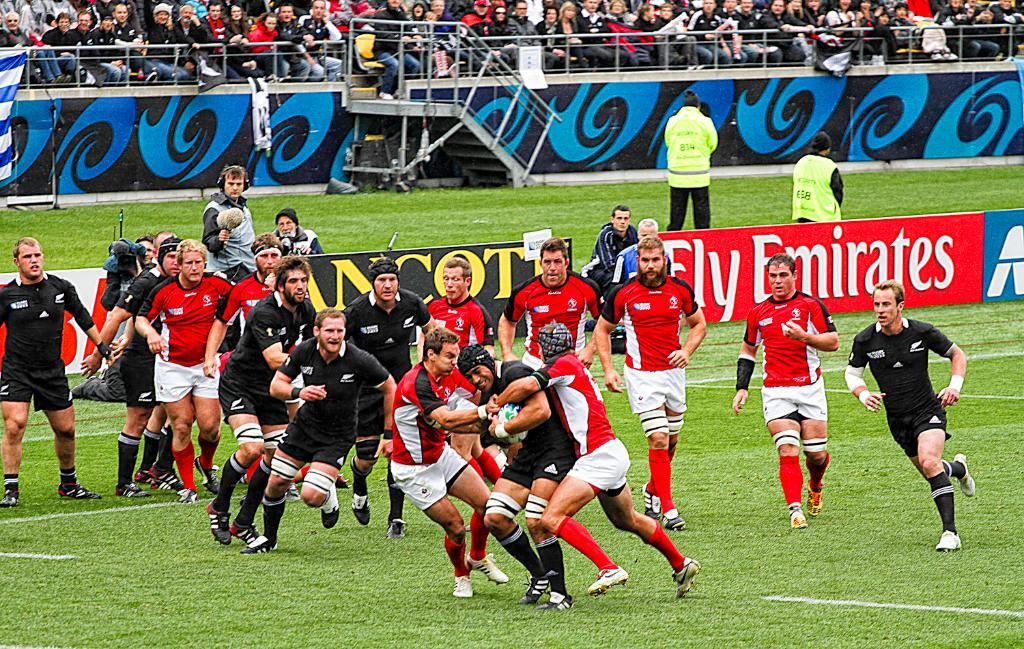<image>
Create a compact narrative representing the image presented. A man is being tackled during a rugby game with sponsors such as Emirates. 